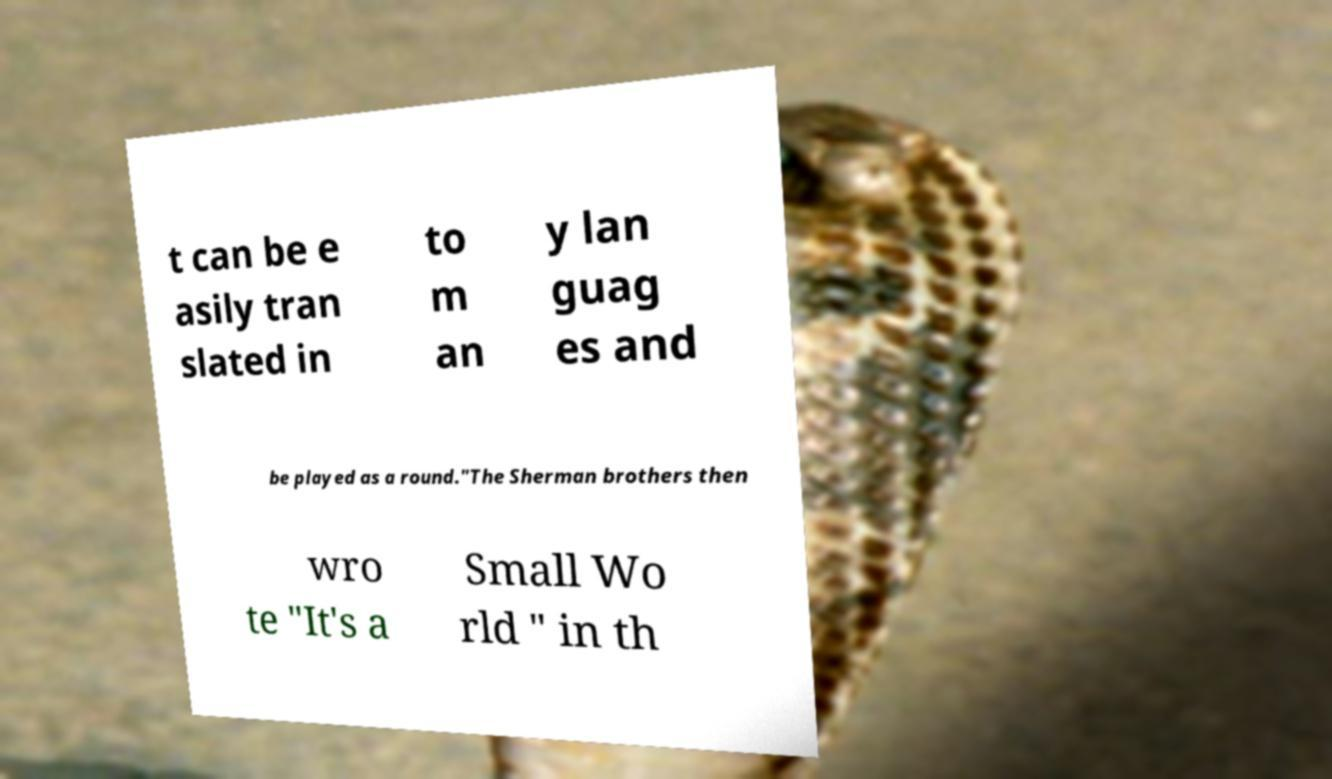What messages or text are displayed in this image? I need them in a readable, typed format. t can be e asily tran slated in to m an y lan guag es and be played as a round."The Sherman brothers then wro te "It's a Small Wo rld " in th 